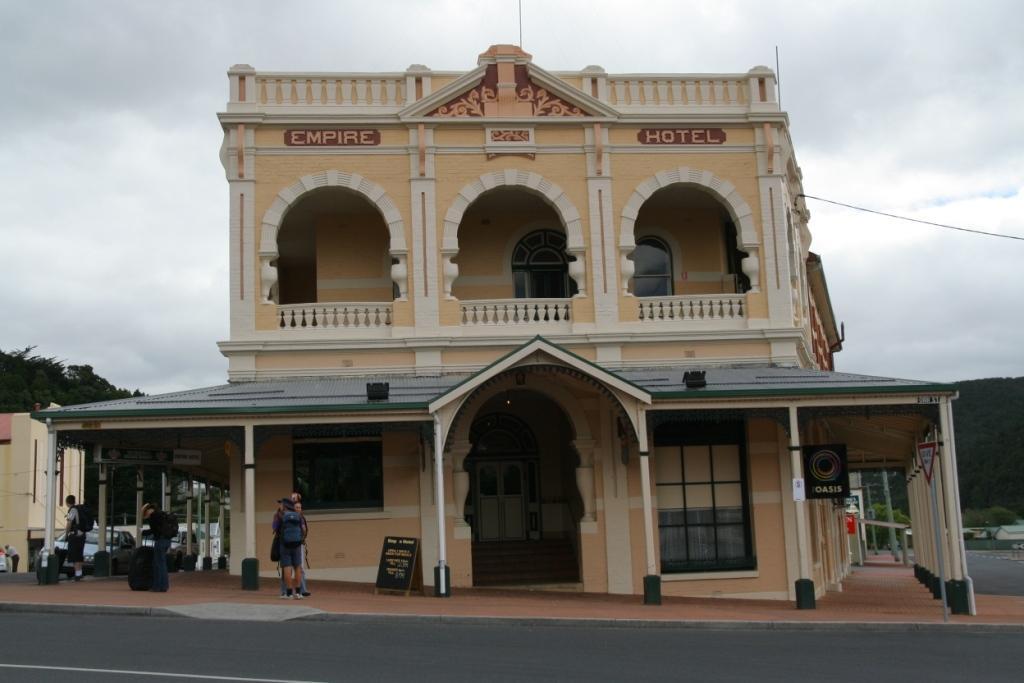Could you give a brief overview of what you see in this image? In the center of the image we can see building. At the bottom of the image we can see persons on road. In the background we can see trees,sky and clouds. 